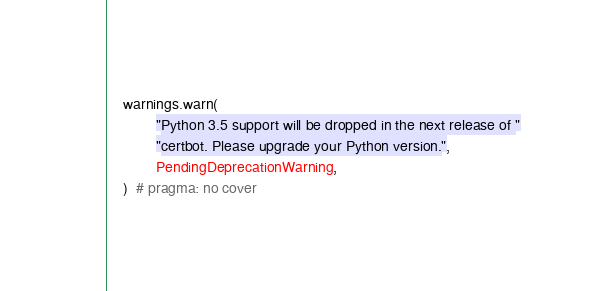Convert code to text. <code><loc_0><loc_0><loc_500><loc_500><_Python_>    warnings.warn(
            "Python 3.5 support will be dropped in the next release of "
            "certbot. Please upgrade your Python version.",
            PendingDeprecationWarning,
    )  # pragma: no cover
</code> 